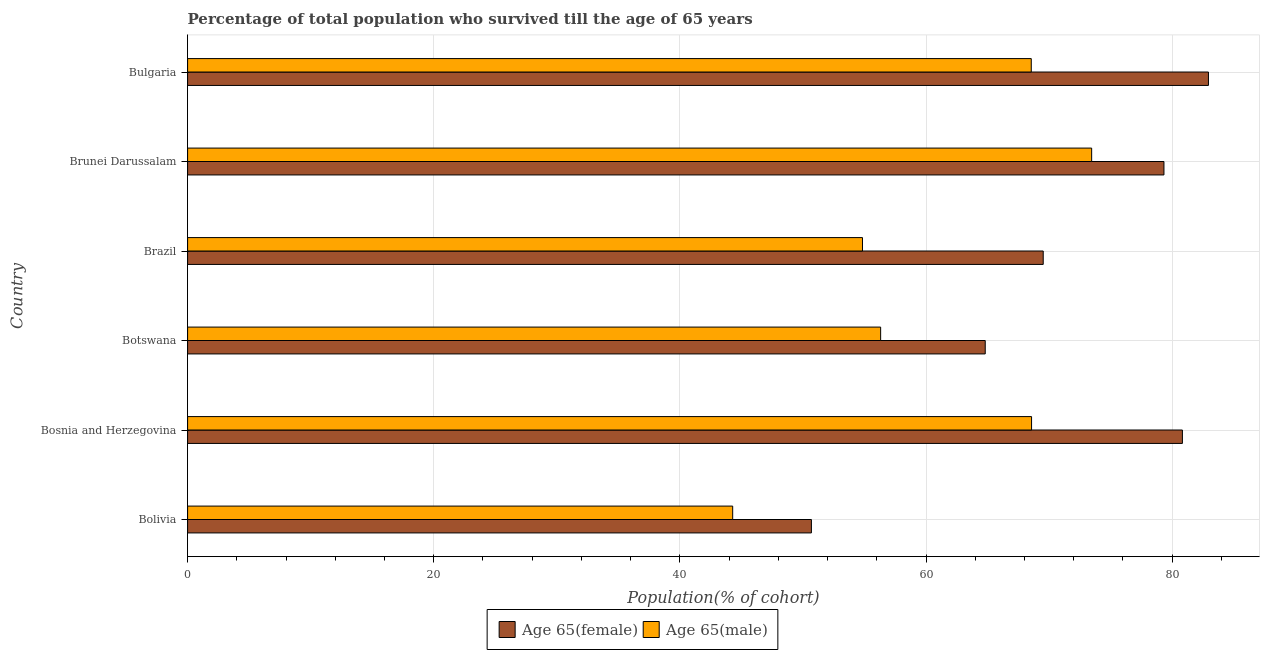Are the number of bars on each tick of the Y-axis equal?
Provide a succinct answer. Yes. What is the label of the 4th group of bars from the top?
Your answer should be compact. Botswana. In how many cases, is the number of bars for a given country not equal to the number of legend labels?
Your answer should be very brief. 0. What is the percentage of male population who survived till age of 65 in Brazil?
Offer a very short reply. 54.84. Across all countries, what is the maximum percentage of male population who survived till age of 65?
Offer a very short reply. 73.46. Across all countries, what is the minimum percentage of female population who survived till age of 65?
Offer a terse response. 50.69. In which country was the percentage of male population who survived till age of 65 minimum?
Ensure brevity in your answer.  Bolivia. What is the total percentage of female population who survived till age of 65 in the graph?
Make the answer very short. 428.12. What is the difference between the percentage of female population who survived till age of 65 in Bolivia and that in Botswana?
Provide a succinct answer. -14.12. What is the difference between the percentage of male population who survived till age of 65 in Botswana and the percentage of female population who survived till age of 65 in Brazil?
Give a very brief answer. -13.21. What is the average percentage of female population who survived till age of 65 per country?
Give a very brief answer. 71.35. What is the difference between the percentage of male population who survived till age of 65 and percentage of female population who survived till age of 65 in Bolivia?
Make the answer very short. -6.4. What is the ratio of the percentage of male population who survived till age of 65 in Botswana to that in Brunei Darussalam?
Make the answer very short. 0.77. Is the percentage of male population who survived till age of 65 in Bolivia less than that in Botswana?
Offer a terse response. Yes. Is the difference between the percentage of female population who survived till age of 65 in Brunei Darussalam and Bulgaria greater than the difference between the percentage of male population who survived till age of 65 in Brunei Darussalam and Bulgaria?
Your answer should be compact. No. What is the difference between the highest and the second highest percentage of female population who survived till age of 65?
Make the answer very short. 2.12. What is the difference between the highest and the lowest percentage of female population who survived till age of 65?
Provide a succinct answer. 32.26. In how many countries, is the percentage of female population who survived till age of 65 greater than the average percentage of female population who survived till age of 65 taken over all countries?
Your answer should be very brief. 3. What does the 1st bar from the top in Botswana represents?
Offer a terse response. Age 65(male). What does the 2nd bar from the bottom in Bulgaria represents?
Offer a very short reply. Age 65(male). How many bars are there?
Provide a short and direct response. 12. What is the difference between two consecutive major ticks on the X-axis?
Provide a short and direct response. 20. Are the values on the major ticks of X-axis written in scientific E-notation?
Your answer should be very brief. No. How many legend labels are there?
Ensure brevity in your answer.  2. What is the title of the graph?
Make the answer very short. Percentage of total population who survived till the age of 65 years. What is the label or title of the X-axis?
Provide a succinct answer. Population(% of cohort). What is the label or title of the Y-axis?
Your response must be concise. Country. What is the Population(% of cohort) in Age 65(female) in Bolivia?
Make the answer very short. 50.69. What is the Population(% of cohort) of Age 65(male) in Bolivia?
Your answer should be very brief. 44.29. What is the Population(% of cohort) of Age 65(female) in Bosnia and Herzegovina?
Give a very brief answer. 80.83. What is the Population(% of cohort) in Age 65(male) in Bosnia and Herzegovina?
Offer a very short reply. 68.57. What is the Population(% of cohort) of Age 65(female) in Botswana?
Provide a short and direct response. 64.81. What is the Population(% of cohort) in Age 65(male) in Botswana?
Ensure brevity in your answer.  56.31. What is the Population(% of cohort) in Age 65(female) in Brazil?
Your answer should be very brief. 69.52. What is the Population(% of cohort) of Age 65(male) in Brazil?
Provide a succinct answer. 54.84. What is the Population(% of cohort) in Age 65(female) in Brunei Darussalam?
Provide a short and direct response. 79.33. What is the Population(% of cohort) in Age 65(male) in Brunei Darussalam?
Your answer should be very brief. 73.46. What is the Population(% of cohort) in Age 65(female) in Bulgaria?
Provide a succinct answer. 82.94. What is the Population(% of cohort) of Age 65(male) in Bulgaria?
Your response must be concise. 68.55. Across all countries, what is the maximum Population(% of cohort) of Age 65(female)?
Keep it short and to the point. 82.94. Across all countries, what is the maximum Population(% of cohort) of Age 65(male)?
Ensure brevity in your answer.  73.46. Across all countries, what is the minimum Population(% of cohort) in Age 65(female)?
Make the answer very short. 50.69. Across all countries, what is the minimum Population(% of cohort) of Age 65(male)?
Your answer should be compact. 44.29. What is the total Population(% of cohort) of Age 65(female) in the graph?
Your answer should be compact. 428.12. What is the total Population(% of cohort) in Age 65(male) in the graph?
Your response must be concise. 366.01. What is the difference between the Population(% of cohort) in Age 65(female) in Bolivia and that in Bosnia and Herzegovina?
Offer a very short reply. -30.14. What is the difference between the Population(% of cohort) in Age 65(male) in Bolivia and that in Bosnia and Herzegovina?
Your answer should be very brief. -24.28. What is the difference between the Population(% of cohort) in Age 65(female) in Bolivia and that in Botswana?
Offer a terse response. -14.12. What is the difference between the Population(% of cohort) in Age 65(male) in Bolivia and that in Botswana?
Provide a succinct answer. -12.02. What is the difference between the Population(% of cohort) in Age 65(female) in Bolivia and that in Brazil?
Your response must be concise. -18.83. What is the difference between the Population(% of cohort) in Age 65(male) in Bolivia and that in Brazil?
Provide a short and direct response. -10.55. What is the difference between the Population(% of cohort) of Age 65(female) in Bolivia and that in Brunei Darussalam?
Keep it short and to the point. -28.64. What is the difference between the Population(% of cohort) of Age 65(male) in Bolivia and that in Brunei Darussalam?
Ensure brevity in your answer.  -29.17. What is the difference between the Population(% of cohort) in Age 65(female) in Bolivia and that in Bulgaria?
Your response must be concise. -32.26. What is the difference between the Population(% of cohort) of Age 65(male) in Bolivia and that in Bulgaria?
Offer a terse response. -24.26. What is the difference between the Population(% of cohort) of Age 65(female) in Bosnia and Herzegovina and that in Botswana?
Your answer should be compact. 16.02. What is the difference between the Population(% of cohort) in Age 65(male) in Bosnia and Herzegovina and that in Botswana?
Your response must be concise. 12.26. What is the difference between the Population(% of cohort) in Age 65(female) in Bosnia and Herzegovina and that in Brazil?
Keep it short and to the point. 11.31. What is the difference between the Population(% of cohort) of Age 65(male) in Bosnia and Herzegovina and that in Brazil?
Provide a short and direct response. 13.74. What is the difference between the Population(% of cohort) in Age 65(female) in Bosnia and Herzegovina and that in Brunei Darussalam?
Keep it short and to the point. 1.5. What is the difference between the Population(% of cohort) in Age 65(male) in Bosnia and Herzegovina and that in Brunei Darussalam?
Offer a very short reply. -4.88. What is the difference between the Population(% of cohort) of Age 65(female) in Bosnia and Herzegovina and that in Bulgaria?
Provide a succinct answer. -2.12. What is the difference between the Population(% of cohort) of Age 65(male) in Bosnia and Herzegovina and that in Bulgaria?
Keep it short and to the point. 0.02. What is the difference between the Population(% of cohort) in Age 65(female) in Botswana and that in Brazil?
Ensure brevity in your answer.  -4.71. What is the difference between the Population(% of cohort) of Age 65(male) in Botswana and that in Brazil?
Keep it short and to the point. 1.47. What is the difference between the Population(% of cohort) in Age 65(female) in Botswana and that in Brunei Darussalam?
Give a very brief answer. -14.52. What is the difference between the Population(% of cohort) in Age 65(male) in Botswana and that in Brunei Darussalam?
Make the answer very short. -17.15. What is the difference between the Population(% of cohort) in Age 65(female) in Botswana and that in Bulgaria?
Offer a terse response. -18.14. What is the difference between the Population(% of cohort) in Age 65(male) in Botswana and that in Bulgaria?
Offer a very short reply. -12.24. What is the difference between the Population(% of cohort) in Age 65(female) in Brazil and that in Brunei Darussalam?
Ensure brevity in your answer.  -9.81. What is the difference between the Population(% of cohort) in Age 65(male) in Brazil and that in Brunei Darussalam?
Your answer should be compact. -18.62. What is the difference between the Population(% of cohort) of Age 65(female) in Brazil and that in Bulgaria?
Give a very brief answer. -13.43. What is the difference between the Population(% of cohort) of Age 65(male) in Brazil and that in Bulgaria?
Ensure brevity in your answer.  -13.71. What is the difference between the Population(% of cohort) in Age 65(female) in Brunei Darussalam and that in Bulgaria?
Give a very brief answer. -3.62. What is the difference between the Population(% of cohort) of Age 65(male) in Brunei Darussalam and that in Bulgaria?
Your answer should be compact. 4.91. What is the difference between the Population(% of cohort) of Age 65(female) in Bolivia and the Population(% of cohort) of Age 65(male) in Bosnia and Herzegovina?
Make the answer very short. -17.89. What is the difference between the Population(% of cohort) of Age 65(female) in Bolivia and the Population(% of cohort) of Age 65(male) in Botswana?
Make the answer very short. -5.62. What is the difference between the Population(% of cohort) of Age 65(female) in Bolivia and the Population(% of cohort) of Age 65(male) in Brazil?
Your answer should be very brief. -4.15. What is the difference between the Population(% of cohort) in Age 65(female) in Bolivia and the Population(% of cohort) in Age 65(male) in Brunei Darussalam?
Give a very brief answer. -22.77. What is the difference between the Population(% of cohort) of Age 65(female) in Bolivia and the Population(% of cohort) of Age 65(male) in Bulgaria?
Make the answer very short. -17.86. What is the difference between the Population(% of cohort) of Age 65(female) in Bosnia and Herzegovina and the Population(% of cohort) of Age 65(male) in Botswana?
Your answer should be compact. 24.52. What is the difference between the Population(% of cohort) in Age 65(female) in Bosnia and Herzegovina and the Population(% of cohort) in Age 65(male) in Brazil?
Your response must be concise. 25.99. What is the difference between the Population(% of cohort) in Age 65(female) in Bosnia and Herzegovina and the Population(% of cohort) in Age 65(male) in Brunei Darussalam?
Provide a succinct answer. 7.37. What is the difference between the Population(% of cohort) of Age 65(female) in Bosnia and Herzegovina and the Population(% of cohort) of Age 65(male) in Bulgaria?
Give a very brief answer. 12.28. What is the difference between the Population(% of cohort) in Age 65(female) in Botswana and the Population(% of cohort) in Age 65(male) in Brazil?
Give a very brief answer. 9.97. What is the difference between the Population(% of cohort) of Age 65(female) in Botswana and the Population(% of cohort) of Age 65(male) in Brunei Darussalam?
Offer a very short reply. -8.65. What is the difference between the Population(% of cohort) of Age 65(female) in Botswana and the Population(% of cohort) of Age 65(male) in Bulgaria?
Your answer should be compact. -3.74. What is the difference between the Population(% of cohort) of Age 65(female) in Brazil and the Population(% of cohort) of Age 65(male) in Brunei Darussalam?
Keep it short and to the point. -3.94. What is the difference between the Population(% of cohort) of Age 65(female) in Brazil and the Population(% of cohort) of Age 65(male) in Bulgaria?
Offer a very short reply. 0.97. What is the difference between the Population(% of cohort) of Age 65(female) in Brunei Darussalam and the Population(% of cohort) of Age 65(male) in Bulgaria?
Your answer should be compact. 10.78. What is the average Population(% of cohort) of Age 65(female) per country?
Offer a terse response. 71.35. What is the average Population(% of cohort) in Age 65(male) per country?
Offer a very short reply. 61. What is the difference between the Population(% of cohort) of Age 65(female) and Population(% of cohort) of Age 65(male) in Bolivia?
Your answer should be compact. 6.4. What is the difference between the Population(% of cohort) in Age 65(female) and Population(% of cohort) in Age 65(male) in Bosnia and Herzegovina?
Provide a short and direct response. 12.26. What is the difference between the Population(% of cohort) in Age 65(female) and Population(% of cohort) in Age 65(male) in Botswana?
Your answer should be very brief. 8.5. What is the difference between the Population(% of cohort) in Age 65(female) and Population(% of cohort) in Age 65(male) in Brazil?
Your answer should be compact. 14.68. What is the difference between the Population(% of cohort) in Age 65(female) and Population(% of cohort) in Age 65(male) in Brunei Darussalam?
Offer a terse response. 5.87. What is the difference between the Population(% of cohort) of Age 65(female) and Population(% of cohort) of Age 65(male) in Bulgaria?
Make the answer very short. 14.4. What is the ratio of the Population(% of cohort) in Age 65(female) in Bolivia to that in Bosnia and Herzegovina?
Give a very brief answer. 0.63. What is the ratio of the Population(% of cohort) in Age 65(male) in Bolivia to that in Bosnia and Herzegovina?
Keep it short and to the point. 0.65. What is the ratio of the Population(% of cohort) of Age 65(female) in Bolivia to that in Botswana?
Provide a succinct answer. 0.78. What is the ratio of the Population(% of cohort) in Age 65(male) in Bolivia to that in Botswana?
Your answer should be compact. 0.79. What is the ratio of the Population(% of cohort) in Age 65(female) in Bolivia to that in Brazil?
Your answer should be compact. 0.73. What is the ratio of the Population(% of cohort) in Age 65(male) in Bolivia to that in Brazil?
Provide a succinct answer. 0.81. What is the ratio of the Population(% of cohort) of Age 65(female) in Bolivia to that in Brunei Darussalam?
Offer a terse response. 0.64. What is the ratio of the Population(% of cohort) in Age 65(male) in Bolivia to that in Brunei Darussalam?
Provide a short and direct response. 0.6. What is the ratio of the Population(% of cohort) in Age 65(female) in Bolivia to that in Bulgaria?
Your response must be concise. 0.61. What is the ratio of the Population(% of cohort) in Age 65(male) in Bolivia to that in Bulgaria?
Your response must be concise. 0.65. What is the ratio of the Population(% of cohort) in Age 65(female) in Bosnia and Herzegovina to that in Botswana?
Your answer should be very brief. 1.25. What is the ratio of the Population(% of cohort) of Age 65(male) in Bosnia and Herzegovina to that in Botswana?
Offer a terse response. 1.22. What is the ratio of the Population(% of cohort) in Age 65(female) in Bosnia and Herzegovina to that in Brazil?
Offer a very short reply. 1.16. What is the ratio of the Population(% of cohort) of Age 65(male) in Bosnia and Herzegovina to that in Brazil?
Keep it short and to the point. 1.25. What is the ratio of the Population(% of cohort) of Age 65(female) in Bosnia and Herzegovina to that in Brunei Darussalam?
Your response must be concise. 1.02. What is the ratio of the Population(% of cohort) of Age 65(male) in Bosnia and Herzegovina to that in Brunei Darussalam?
Offer a terse response. 0.93. What is the ratio of the Population(% of cohort) in Age 65(female) in Bosnia and Herzegovina to that in Bulgaria?
Keep it short and to the point. 0.97. What is the ratio of the Population(% of cohort) of Age 65(male) in Bosnia and Herzegovina to that in Bulgaria?
Make the answer very short. 1. What is the ratio of the Population(% of cohort) of Age 65(female) in Botswana to that in Brazil?
Your response must be concise. 0.93. What is the ratio of the Population(% of cohort) of Age 65(male) in Botswana to that in Brazil?
Your answer should be compact. 1.03. What is the ratio of the Population(% of cohort) of Age 65(female) in Botswana to that in Brunei Darussalam?
Give a very brief answer. 0.82. What is the ratio of the Population(% of cohort) in Age 65(male) in Botswana to that in Brunei Darussalam?
Give a very brief answer. 0.77. What is the ratio of the Population(% of cohort) in Age 65(female) in Botswana to that in Bulgaria?
Provide a succinct answer. 0.78. What is the ratio of the Population(% of cohort) of Age 65(male) in Botswana to that in Bulgaria?
Give a very brief answer. 0.82. What is the ratio of the Population(% of cohort) in Age 65(female) in Brazil to that in Brunei Darussalam?
Your response must be concise. 0.88. What is the ratio of the Population(% of cohort) of Age 65(male) in Brazil to that in Brunei Darussalam?
Give a very brief answer. 0.75. What is the ratio of the Population(% of cohort) of Age 65(female) in Brazil to that in Bulgaria?
Provide a succinct answer. 0.84. What is the ratio of the Population(% of cohort) of Age 65(male) in Brazil to that in Bulgaria?
Your answer should be compact. 0.8. What is the ratio of the Population(% of cohort) of Age 65(female) in Brunei Darussalam to that in Bulgaria?
Offer a terse response. 0.96. What is the ratio of the Population(% of cohort) in Age 65(male) in Brunei Darussalam to that in Bulgaria?
Offer a very short reply. 1.07. What is the difference between the highest and the second highest Population(% of cohort) in Age 65(female)?
Give a very brief answer. 2.12. What is the difference between the highest and the second highest Population(% of cohort) in Age 65(male)?
Keep it short and to the point. 4.88. What is the difference between the highest and the lowest Population(% of cohort) of Age 65(female)?
Offer a very short reply. 32.26. What is the difference between the highest and the lowest Population(% of cohort) in Age 65(male)?
Give a very brief answer. 29.17. 